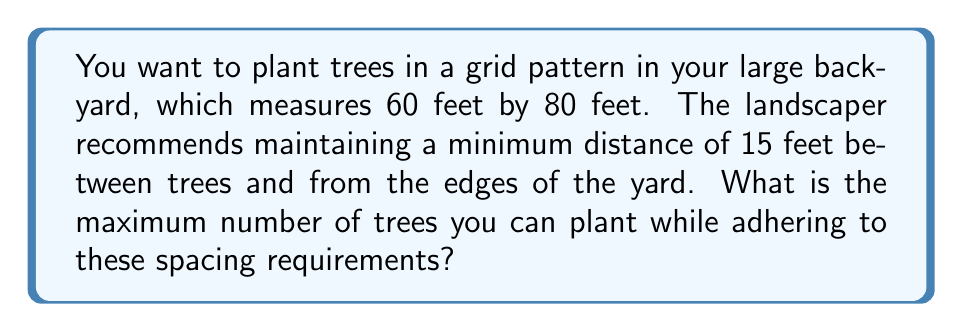Help me with this question. Let's approach this step-by-step:

1) First, we need to calculate the available space for planting after accounting for the edge requirements:
   - Width: $60 - (2 \times 15) = 30$ feet
   - Length: $80 - (2 \times 15) = 50$ feet

2) Now, we need to determine how many trees can fit in each direction:
   - Width: $30 \div 15 = 2$ trees
   - Length: $50 \div 15 = 3.33$ trees

3) Since we can't plant partial trees, we round down to the nearest whole number:
   - Width: 2 trees
   - Length: 3 trees

4) To find the total number of trees, we multiply:
   $$\text{Total trees} = 2 \times 3 = 6$$

5) Let's verify this visually:

[asy]
unitsize(2mm);
draw((0,0)--(80,0)--(80,60)--(0,60)--cycle);
for(int i=15; i<=65; i+=25) {
  for(int j=15; j<=45; j+=15) {
    dot((i,j));
  }
}
label("80'",(40,-3));
label("60'",(83,30));
[/asy]

The diagram shows that 6 trees (represented by dots) can indeed fit in the yard while maintaining the required spacing.
Answer: 6 trees 